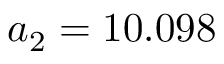<formula> <loc_0><loc_0><loc_500><loc_500>a _ { 2 } = 1 0 . 0 9 8</formula> 